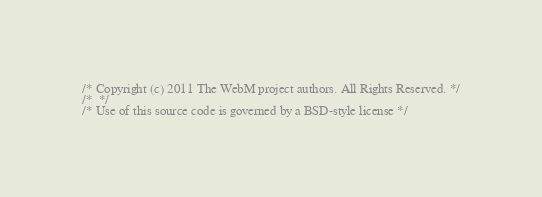Convert code to text. <code><loc_0><loc_0><loc_500><loc_500><_C_>/* Copyright (c) 2011 The WebM project authors. All Rights Reserved. */
/*  */
/* Use of this source code is governed by a BSD-style license */</code> 